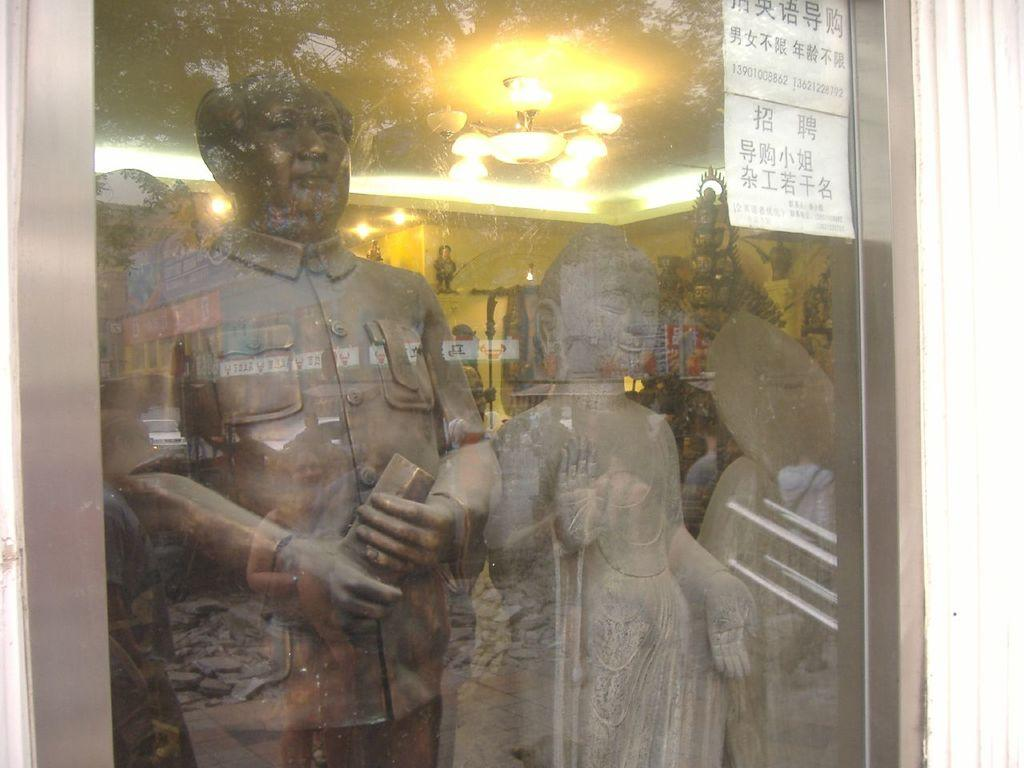What type of window is present in the image? There is a glass window in the image. What can be seen through the window? Sculptures and other objects are visible through the window. What type of record can be heard playing in the background of the image? There is no record playing in the background of the image, as the facts provided do not mention any sound or music. 